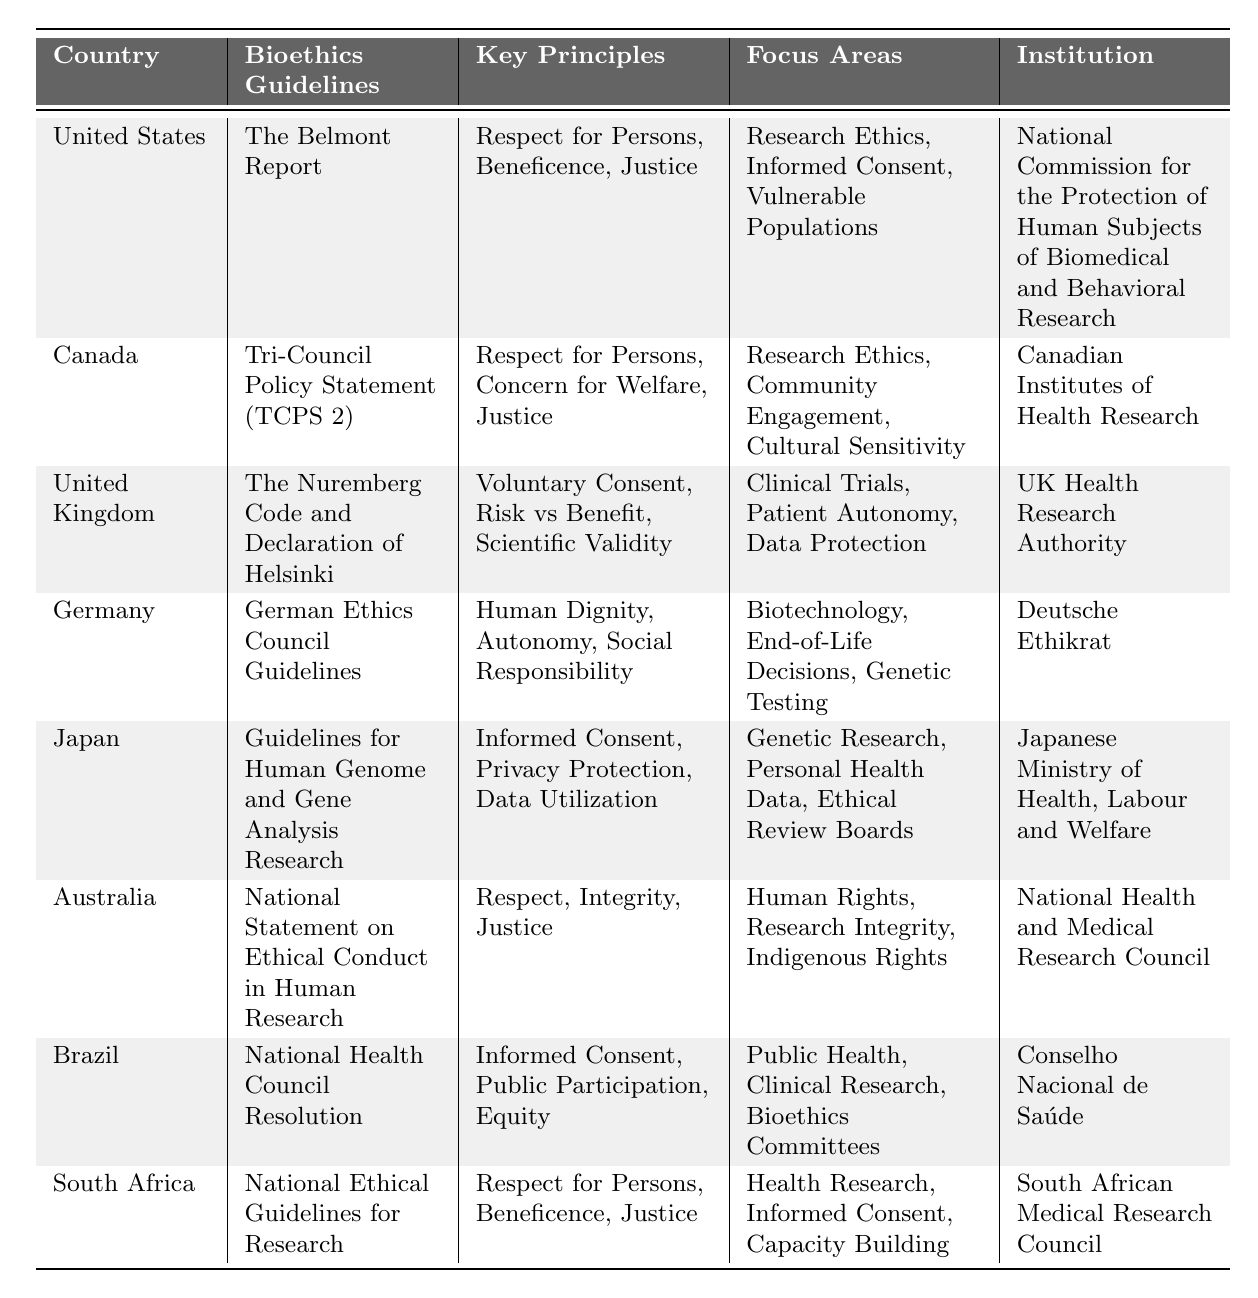What bioethics guidelines does Germany follow? According to the table, Germany follows the "German Ethics Council Guidelines."
Answer: German Ethics Council Guidelines Which country emphasizes "Informed Consent" as a key principle? By checking the table, "Informed Consent" is mentioned as a key principle for multiple countries: the United States, Japan, Brazil, and South Africa.
Answer: United States, Japan, Brazil, South Africa How many countries focus on "Research Ethics"? The table lists several countries focusing on "Research Ethics": the United States, Canada, Australia, and South Africa. A count of these entries shows there are four countries.
Answer: 4 Does Canada have a focus area related to "Cultural Sensitivity"? The table indicates that Canada specifies "Cultural Sensitivity" as one of its focus areas in its bioethics guidelines.
Answer: Yes Which country's guidelines include "Respect for Persons" as a key principle? Both the United States and South Africa list "Respect for Persons" among their key principles according to the table.
Answer: United States, South Africa What is the primary institution responsible for bioethics guidelines in Japan? Referring to the table, Japan’s details show that the "Japanese Ministry of Health, Labour and Welfare" is the institution associated with its bioethics guidelines.
Answer: Japanese Ministry of Health, Labour and Welfare Compare the key principles between the United Kingdom and Australia. The United Kingdom lists "Voluntary Consent," "Risk vs Benefit," and "Scientific Validity." In contrast, Australia emphasizes "Respect," "Integrity," and "Justice." The comparison illustrates differing focuses on consent and integrity.
Answer: UK: Voluntary Consent, Risk vs Benefit, Scientific Validity; Australia: Respect, Integrity, Justice Which country utilizes "National Health Council Resolution" for its bioethics? The table states that Brazil follows the "National Health Council Resolution" for its bioethics guidelines.
Answer: Brazil Identify the country with a strong emphasis on "Indigenous Rights" in its focus areas. Upon examining the table, it reveals that Australia includes "Indigenous Rights" as a focus area in its bioethics guidelines.
Answer: Australia What principles do both the United States and South Africa share? By comparing the key principles listed for both the United States and South Africa, both include "Respect for Persons," "Beneficence," and "Justice."
Answer: Respect for Persons, Beneficence, Justice 